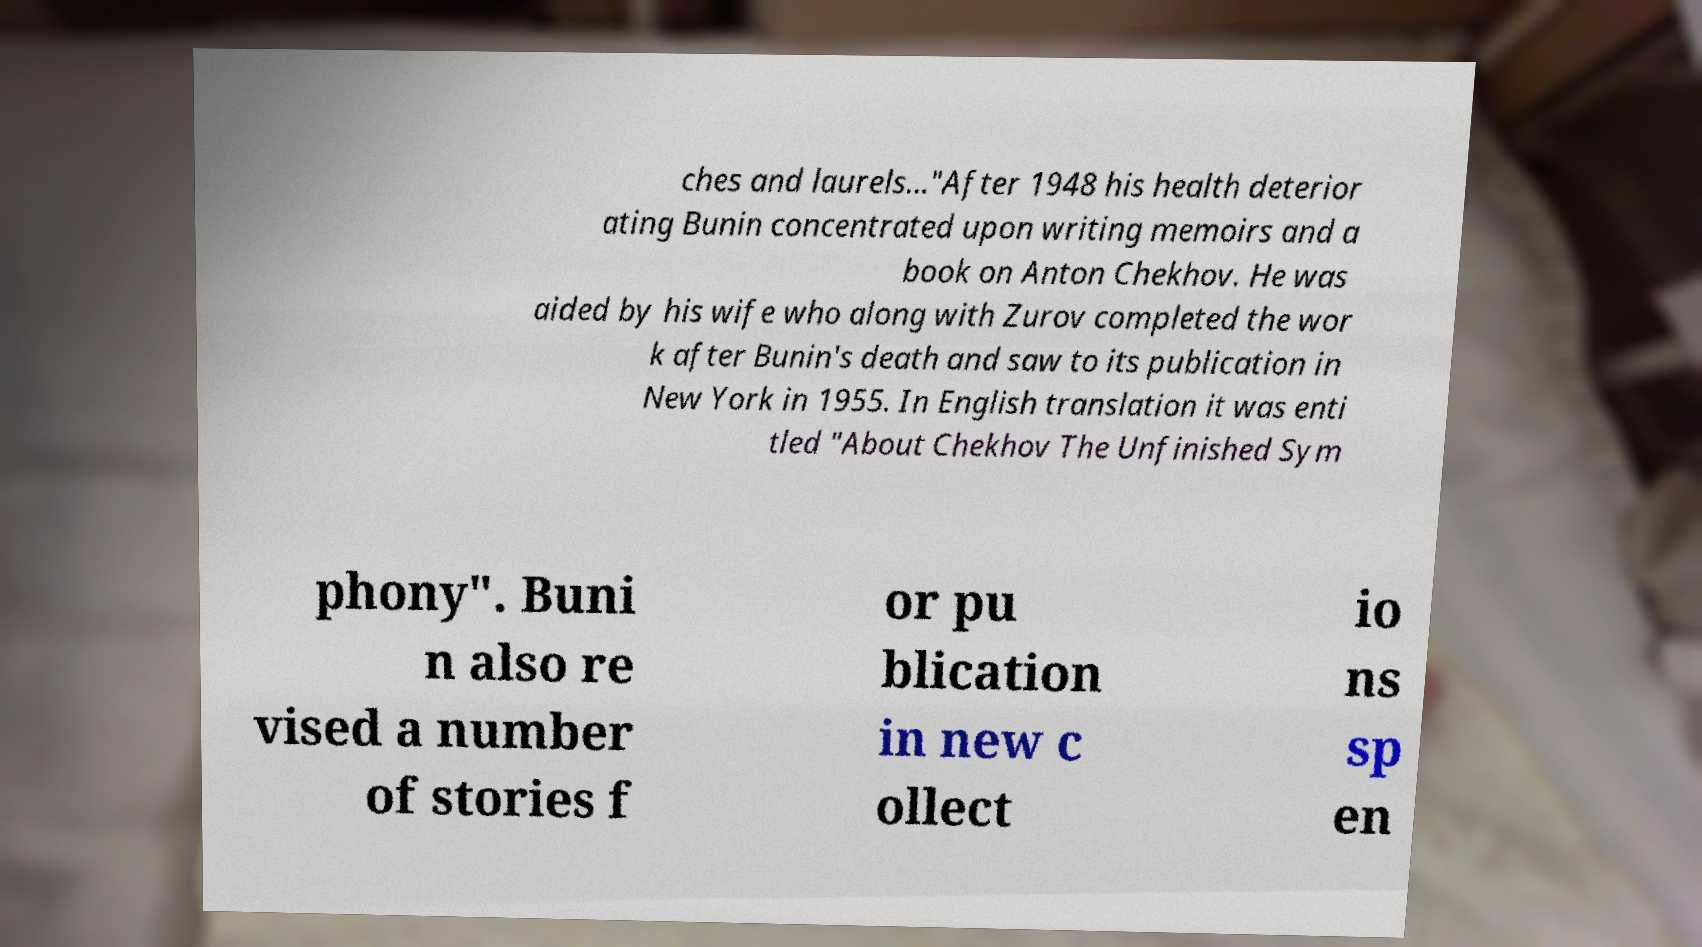Can you read and provide the text displayed in the image?This photo seems to have some interesting text. Can you extract and type it out for me? ches and laurels..."After 1948 his health deterior ating Bunin concentrated upon writing memoirs and a book on Anton Chekhov. He was aided by his wife who along with Zurov completed the wor k after Bunin's death and saw to its publication in New York in 1955. In English translation it was enti tled "About Chekhov The Unfinished Sym phony". Buni n also re vised a number of stories f or pu blication in new c ollect io ns sp en 